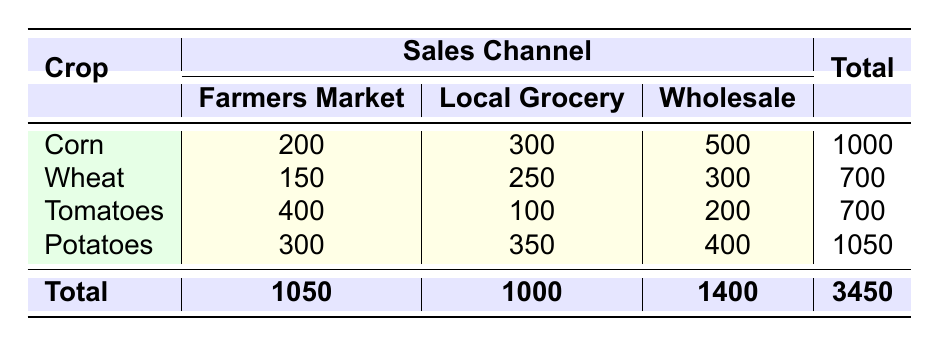What is the total number of units sold for Corn? In the table, for Corn, the units sold are listed as 200 for Farmers Market, 300 for Local Grocery, and 500 for Wholesale. To find the total, we add these numbers: 200 + 300 + 500 = 1000.
Answer: 1000 What is the average price per ton of Wheat in the Summer? From the table, the average price per ton of Wheat in the Summer is 220. This value is directly referenced in the table without any further calculation needed.
Answer: 220 Did Tomatoes sell more units through Farmers Markets or Local Grocery in the Summer? According to the table, Tomatoes sold 400 units at Farmers Market and 100 units at Local Grocery in the Summer. Since 400 is greater than 100, it indicates that more units were sold through Farmers Markets.
Answer: Yes What is the combined total of units sold in all sales channels for Potatoes? For Potatoes, the units sold are listed as 300 for Farmers Market, 350 for Local Grocery, and 400 for Wholesale. Adding these gives us: 300 + 350 + 400 = 1050, which represents the total units sold across all channels for Potatoes.
Answer: 1050 Which sales channel had the highest total units sold across all crops? By looking at the totals for each sales channel, the Farmers Market has 1050 units, Local Grocery has 1000 units, and Wholesale has 1400 units. The highest total is 1400, which is for the Wholesale channel.
Answer: Wholesale What is the seasonal trend in average price per ton for Corn from Spring to Fall? The average prices for Corn are 150 in Spring, 180 in Summer, and 170 in Fall. To identify the trend, we compare these prices: Spring to Summer shows an increase (150 to 180), and Summer to Fall shows a decrease (180 to 170).
Answer: Increase then decrease Is it true that Wheat was sold more in the Wholesale channel than tomatoes were sold in the Local Grocery? Wheat had 300 units sold in the Wholesale channel and Tomatoes had 100 units in the Local Grocery. Since 300 is greater than 100, the statement is true.
Answer: True What is the total number of units sold in the Summer across all crops? In the Summer, the units sold are: Corn (300), Wheat (150), Tomatoes (400), and Potatoes (300). The total is calculated as 300 + 150 + 400 + 300 = 1150.
Answer: 1150 Which crop had the lowest average price per ton in the Spring season? In the Spring, the average prices per ton are: Corn (150), Wheat (200), Tomatoes (300), and Potatoes (120). The lowest of these prices is for Potatoes at 120.
Answer: Potatoes 